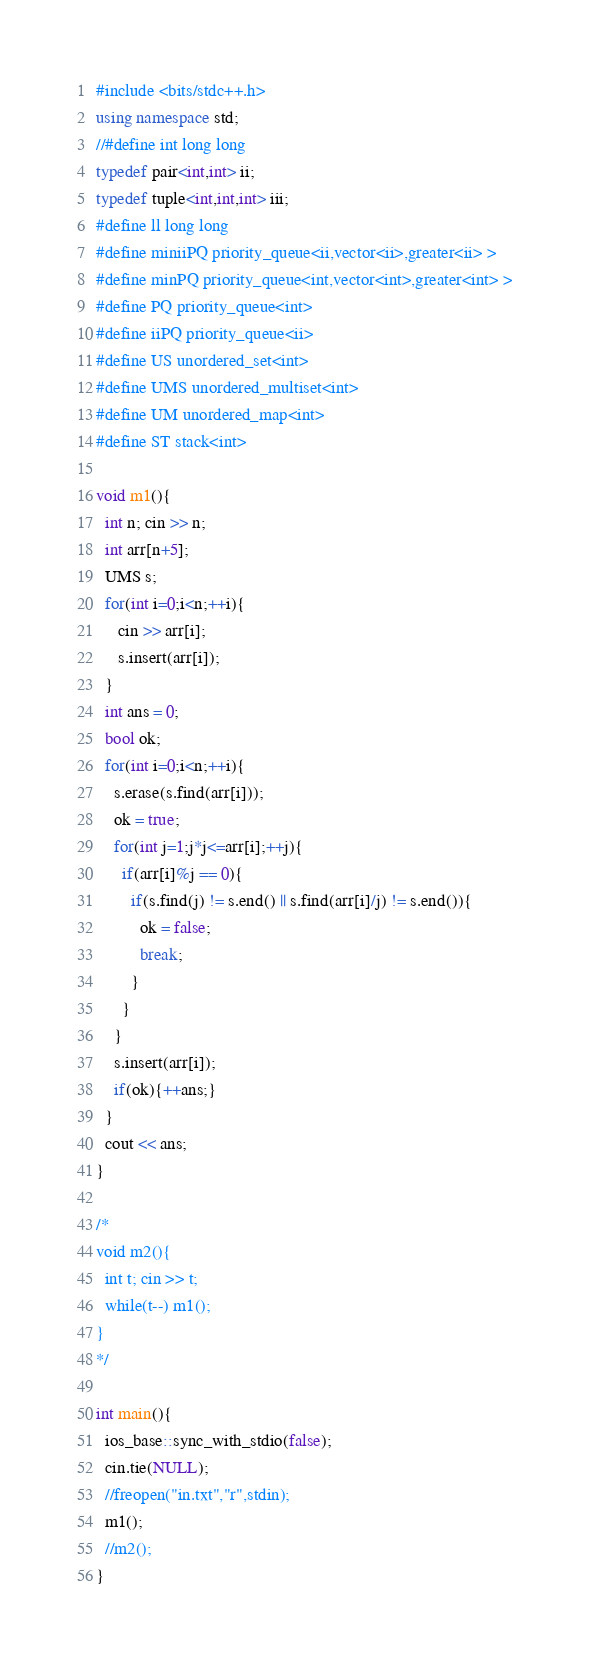<code> <loc_0><loc_0><loc_500><loc_500><_C++_>#include <bits/stdc++.h>
using namespace std;
//#define int long long
typedef pair<int,int> ii;
typedef tuple<int,int,int> iii;
#define ll long long
#define miniiPQ priority_queue<ii,vector<ii>,greater<ii> >
#define minPQ priority_queue<int,vector<int>,greater<int> >
#define PQ priority_queue<int>
#define iiPQ priority_queue<ii>
#define US unordered_set<int>
#define UMS unordered_multiset<int>
#define UM unordered_map<int>
#define ST stack<int>
 
void m1(){
  int n; cin >> n;
  int arr[n+5];
  UMS s;
  for(int i=0;i<n;++i){
     cin >> arr[i];
     s.insert(arr[i]);
  }
  int ans = 0;
  bool ok;
  for(int i=0;i<n;++i){
    s.erase(s.find(arr[i]));
    ok = true;
    for(int j=1;j*j<=arr[i];++j){
      if(arr[i]%j == 0){
        if(s.find(j) != s.end() || s.find(arr[i]/j) != s.end()){
          ok = false;
          break;
        }
      }
    }
    s.insert(arr[i]);
    if(ok){++ans;}
  }
  cout << ans;
}
 
/*
void m2(){
  int t; cin >> t;
  while(t--) m1();
}
*/
 
int main(){
  ios_base::sync_with_stdio(false);
  cin.tie(NULL);
  //freopen("in.txt","r",stdin);
  m1();
  //m2();
}</code> 